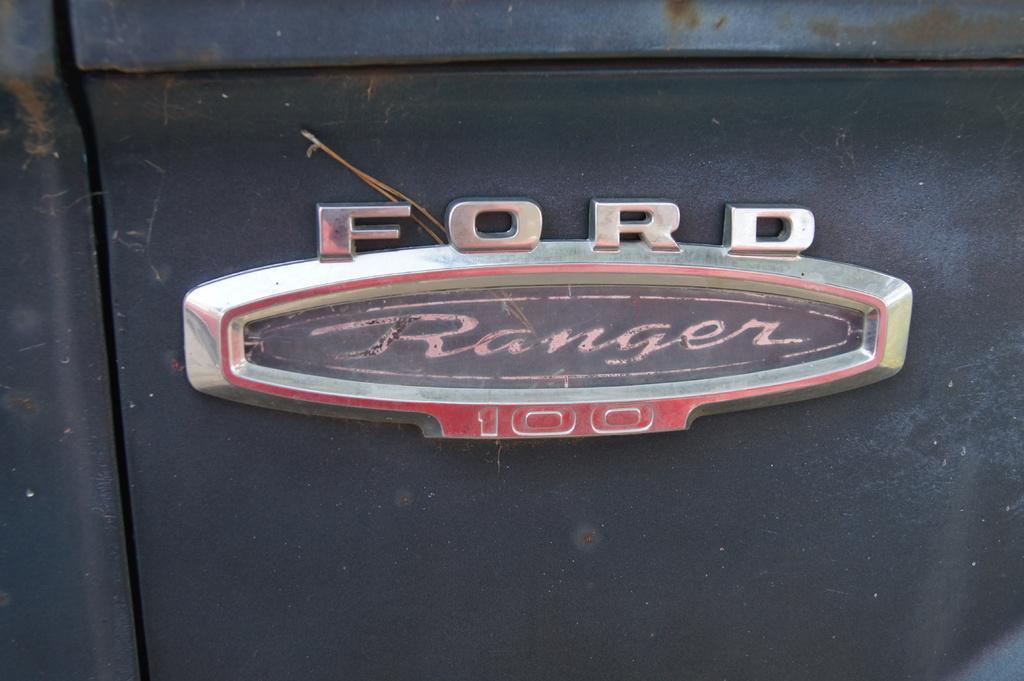In one or two sentences, can you explain what this image depicts? In this image I can see a logo which is made up of metal and I can see some text on it. This is attached to another metal object. 